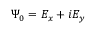Convert formula to latex. <formula><loc_0><loc_0><loc_500><loc_500>\Psi _ { 0 } = E _ { x } + i E _ { y }</formula> 